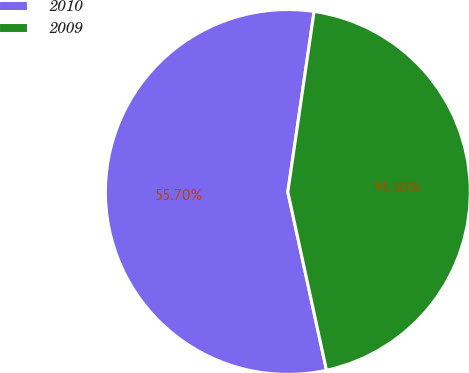Convert chart to OTSL. <chart><loc_0><loc_0><loc_500><loc_500><pie_chart><fcel>2010<fcel>2009<nl><fcel>55.7%<fcel>44.3%<nl></chart> 